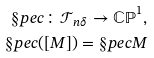Convert formula to latex. <formula><loc_0><loc_0><loc_500><loc_500>\S p e c \colon \mathcal { T } _ { n \delta } \rightarrow \mathbb { C P } ^ { 1 } , \\ \S p e c ( [ M ] ) = \S p e c M</formula> 